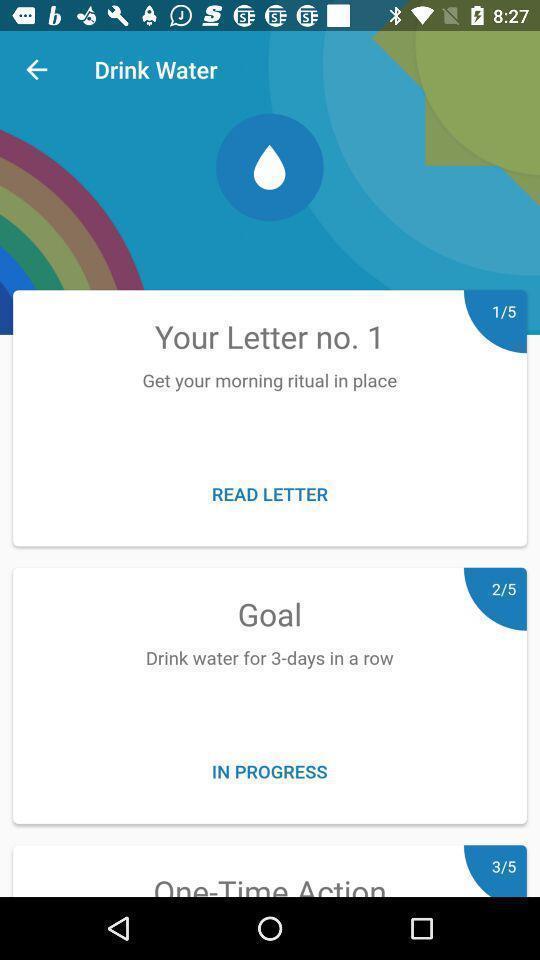Give me a summary of this screen capture. Screen displaying health care app. 